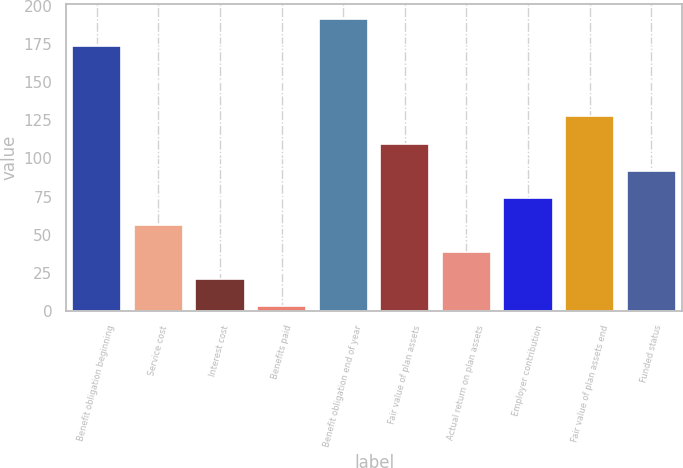Convert chart to OTSL. <chart><loc_0><loc_0><loc_500><loc_500><bar_chart><fcel>Benefit obligation beginning<fcel>Service cost<fcel>Interest cost<fcel>Benefits paid<fcel>Benefit obligation end of year<fcel>Fair value of plan assets<fcel>Actual return on plan assets<fcel>Employer contribution<fcel>Fair value of plan assets end<fcel>Funded status<nl><fcel>173.8<fcel>56.4<fcel>20.8<fcel>3<fcel>191.6<fcel>109.8<fcel>38.6<fcel>74.2<fcel>127.6<fcel>92<nl></chart> 